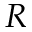Convert formula to latex. <formula><loc_0><loc_0><loc_500><loc_500>R</formula> 